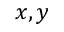Convert formula to latex. <formula><loc_0><loc_0><loc_500><loc_500>x , y</formula> 